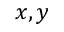Convert formula to latex. <formula><loc_0><loc_0><loc_500><loc_500>x , y</formula> 